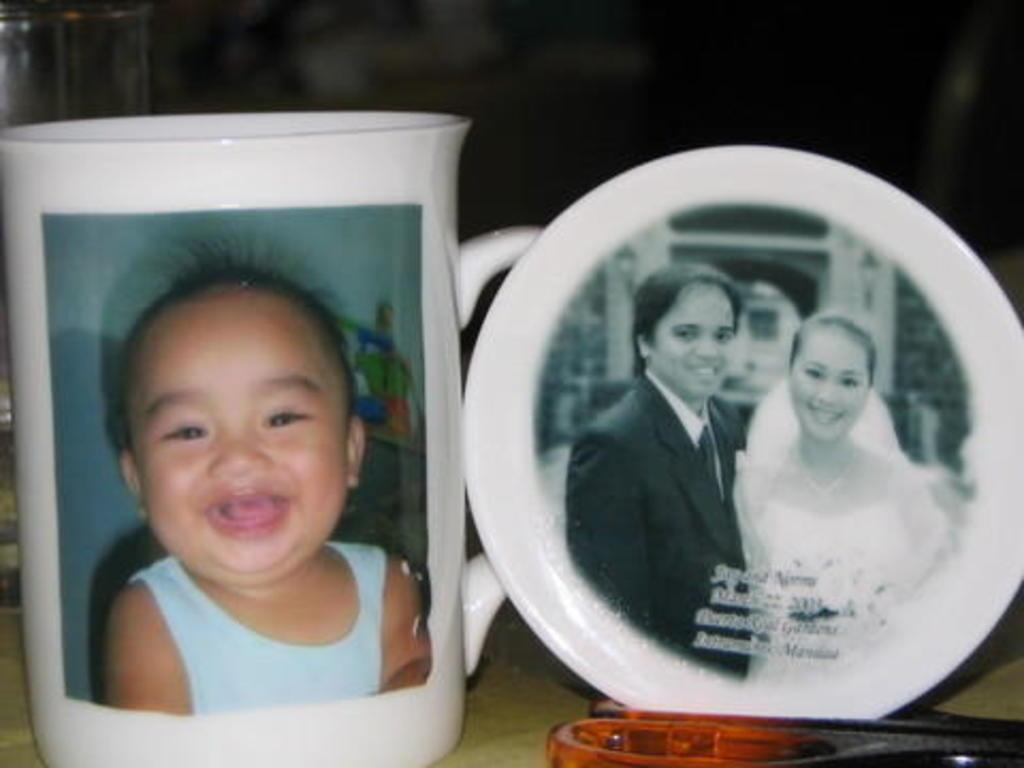What is present on the table in the image? There is a mug and a saucer in the image. What can be seen on the mug and saucer? The mug and saucer have pictures of a baby and people. What is placed in front of the saucer? There is an object in front of the saucer. How would you describe the overall lighting in the image? The background of the image is dark. What type of pancake is being served on the saucer in the image? There is no pancake present in the image; the saucer has a picture of people and a baby. What kind of wood is used to make the mug in the image? The facts do not mention the material used to make the mug, and there is no indication of wood in the image. 